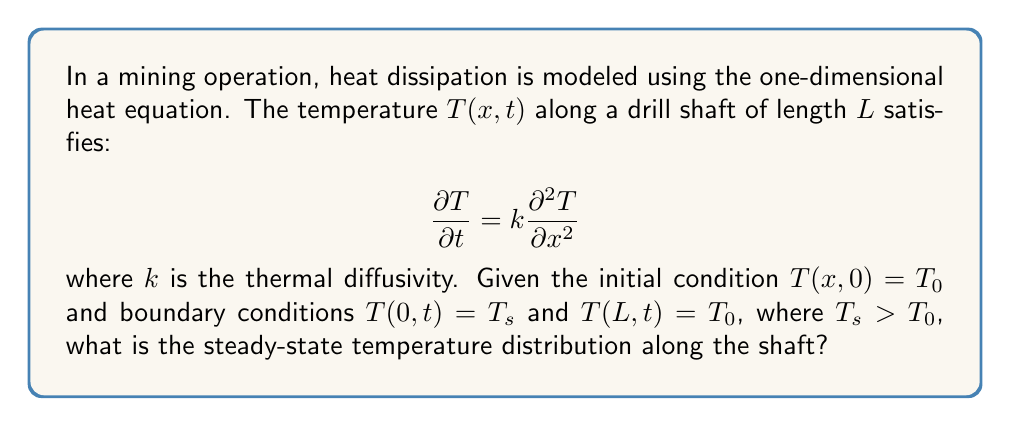Can you solve this math problem? To solve this problem, we follow these steps:

1) For the steady-state solution, $\frac{\partial T}{\partial t} = 0$, so the heat equation reduces to:

   $$0 = k\frac{\partial^2 T}{\partial x^2}$$

2) Integrating twice with respect to $x$:

   $$T(x) = Ax + B$$

   where $A$ and $B$ are constants to be determined.

3) Apply the boundary conditions:
   At $x = 0$: $T(0) = T_s = B$
   At $x = L$: $T(L) = T_0 = AL + T_s$

4) Solve for $A$:
   $$A = \frac{T_0 - T_s}{L}$$

5) Therefore, the steady-state temperature distribution is:

   $$T(x) = \frac{T_0 - T_s}{L}x + T_s$$

6) This can be rewritten as:

   $$T(x) = T_s + (T_0 - T_s)\frac{x}{L}$$

This linear distribution shows that the temperature decreases steadily from $T_s$ at the surface ($x = 0$) to $T_0$ at the end of the shaft ($x = L$).
Answer: $T(x) = T_s + (T_0 - T_s)\frac{x}{L}$ 